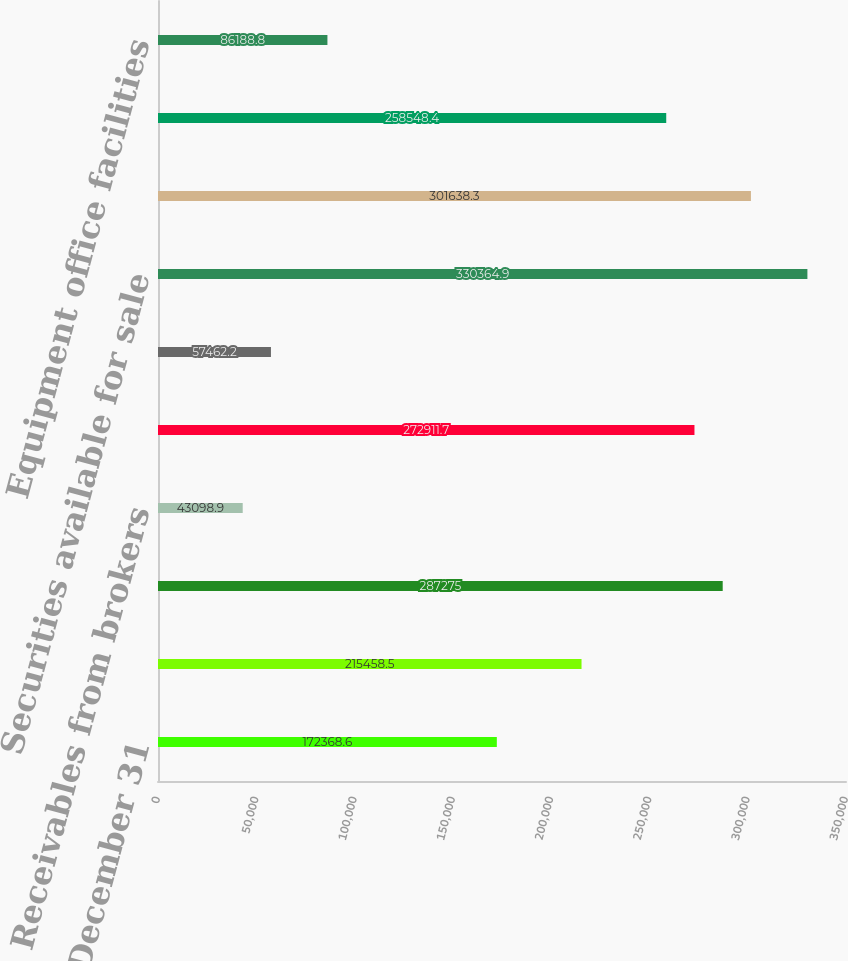Convert chart to OTSL. <chart><loc_0><loc_0><loc_500><loc_500><bar_chart><fcel>December 31<fcel>Cash and cash equivalents<fcel>Cash and investments<fcel>Receivables from brokers<fcel>Receivables from brokerage<fcel>Other securities owned - at<fcel>Securities available for sale<fcel>Securities held to maturity<fcel>Loans to banking clients - net<fcel>Equipment office facilities<nl><fcel>172369<fcel>215458<fcel>287275<fcel>43098.9<fcel>272912<fcel>57462.2<fcel>330365<fcel>301638<fcel>258548<fcel>86188.8<nl></chart> 